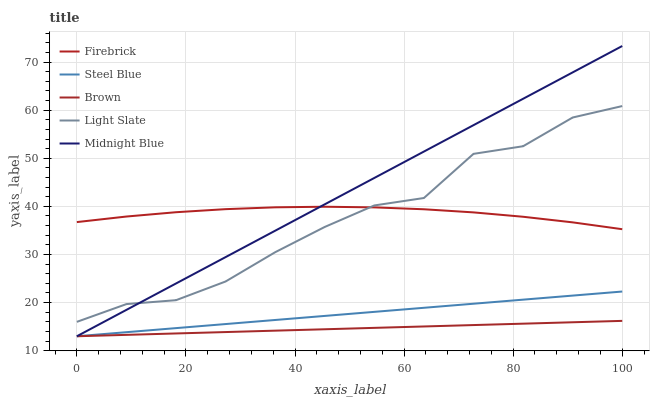Does Brown have the minimum area under the curve?
Answer yes or no. Yes. Does Midnight Blue have the maximum area under the curve?
Answer yes or no. Yes. Does Firebrick have the minimum area under the curve?
Answer yes or no. No. Does Firebrick have the maximum area under the curve?
Answer yes or no. No. Is Brown the smoothest?
Answer yes or no. Yes. Is Light Slate the roughest?
Answer yes or no. Yes. Is Firebrick the smoothest?
Answer yes or no. No. Is Firebrick the roughest?
Answer yes or no. No. Does Brown have the lowest value?
Answer yes or no. Yes. Does Firebrick have the lowest value?
Answer yes or no. No. Does Midnight Blue have the highest value?
Answer yes or no. Yes. Does Firebrick have the highest value?
Answer yes or no. No. Is Steel Blue less than Light Slate?
Answer yes or no. Yes. Is Firebrick greater than Steel Blue?
Answer yes or no. Yes. Does Midnight Blue intersect Steel Blue?
Answer yes or no. Yes. Is Midnight Blue less than Steel Blue?
Answer yes or no. No. Is Midnight Blue greater than Steel Blue?
Answer yes or no. No. Does Steel Blue intersect Light Slate?
Answer yes or no. No. 